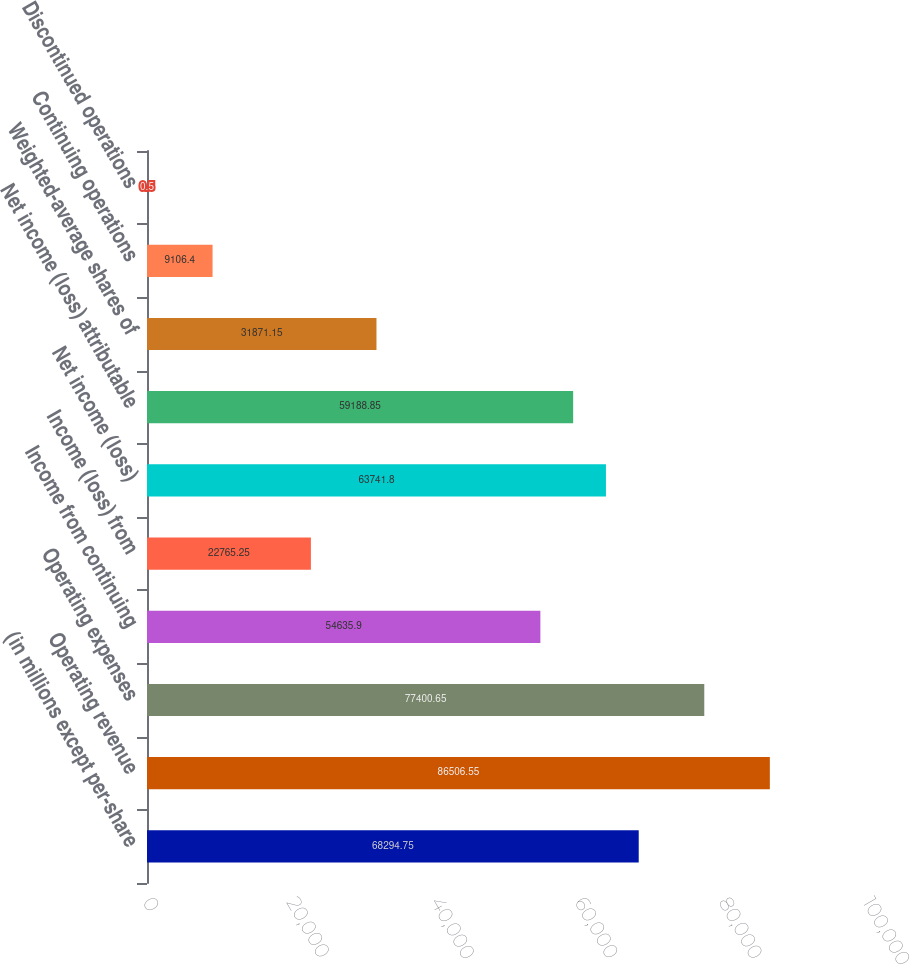<chart> <loc_0><loc_0><loc_500><loc_500><bar_chart><fcel>(in millions except per-share<fcel>Operating revenue<fcel>Operating expenses<fcel>Income from continuing<fcel>Income (loss) from<fcel>Net income (loss)<fcel>Net income (loss) attributable<fcel>Weighted-average shares of<fcel>Continuing operations<fcel>Discontinued operations<nl><fcel>68294.8<fcel>86506.6<fcel>77400.6<fcel>54635.9<fcel>22765.2<fcel>63741.8<fcel>59188.8<fcel>31871.2<fcel>9106.4<fcel>0.5<nl></chart> 